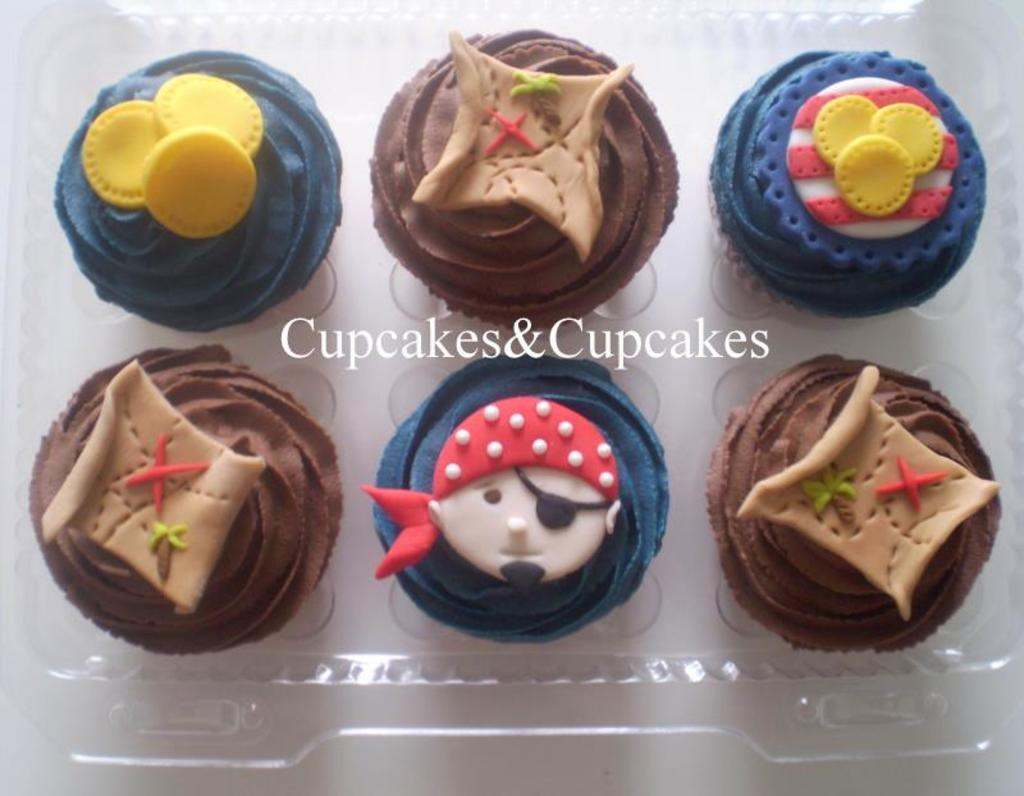What type of food can be seen in the image? There are cupcakes in the image. How are the cupcakes contained in the image? The cupcakes are in a box. Where is the box with cupcakes located? The box is on a table. Is there any text present in the image? Yes, there is text present in the image. Can you tell me what the horse is doing in the image? There is no horse present in the image; it only features cupcakes in a box on a table with text. 